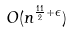Convert formula to latex. <formula><loc_0><loc_0><loc_500><loc_500>O ( n ^ { \frac { 1 1 } { 2 } + \epsilon } )</formula> 